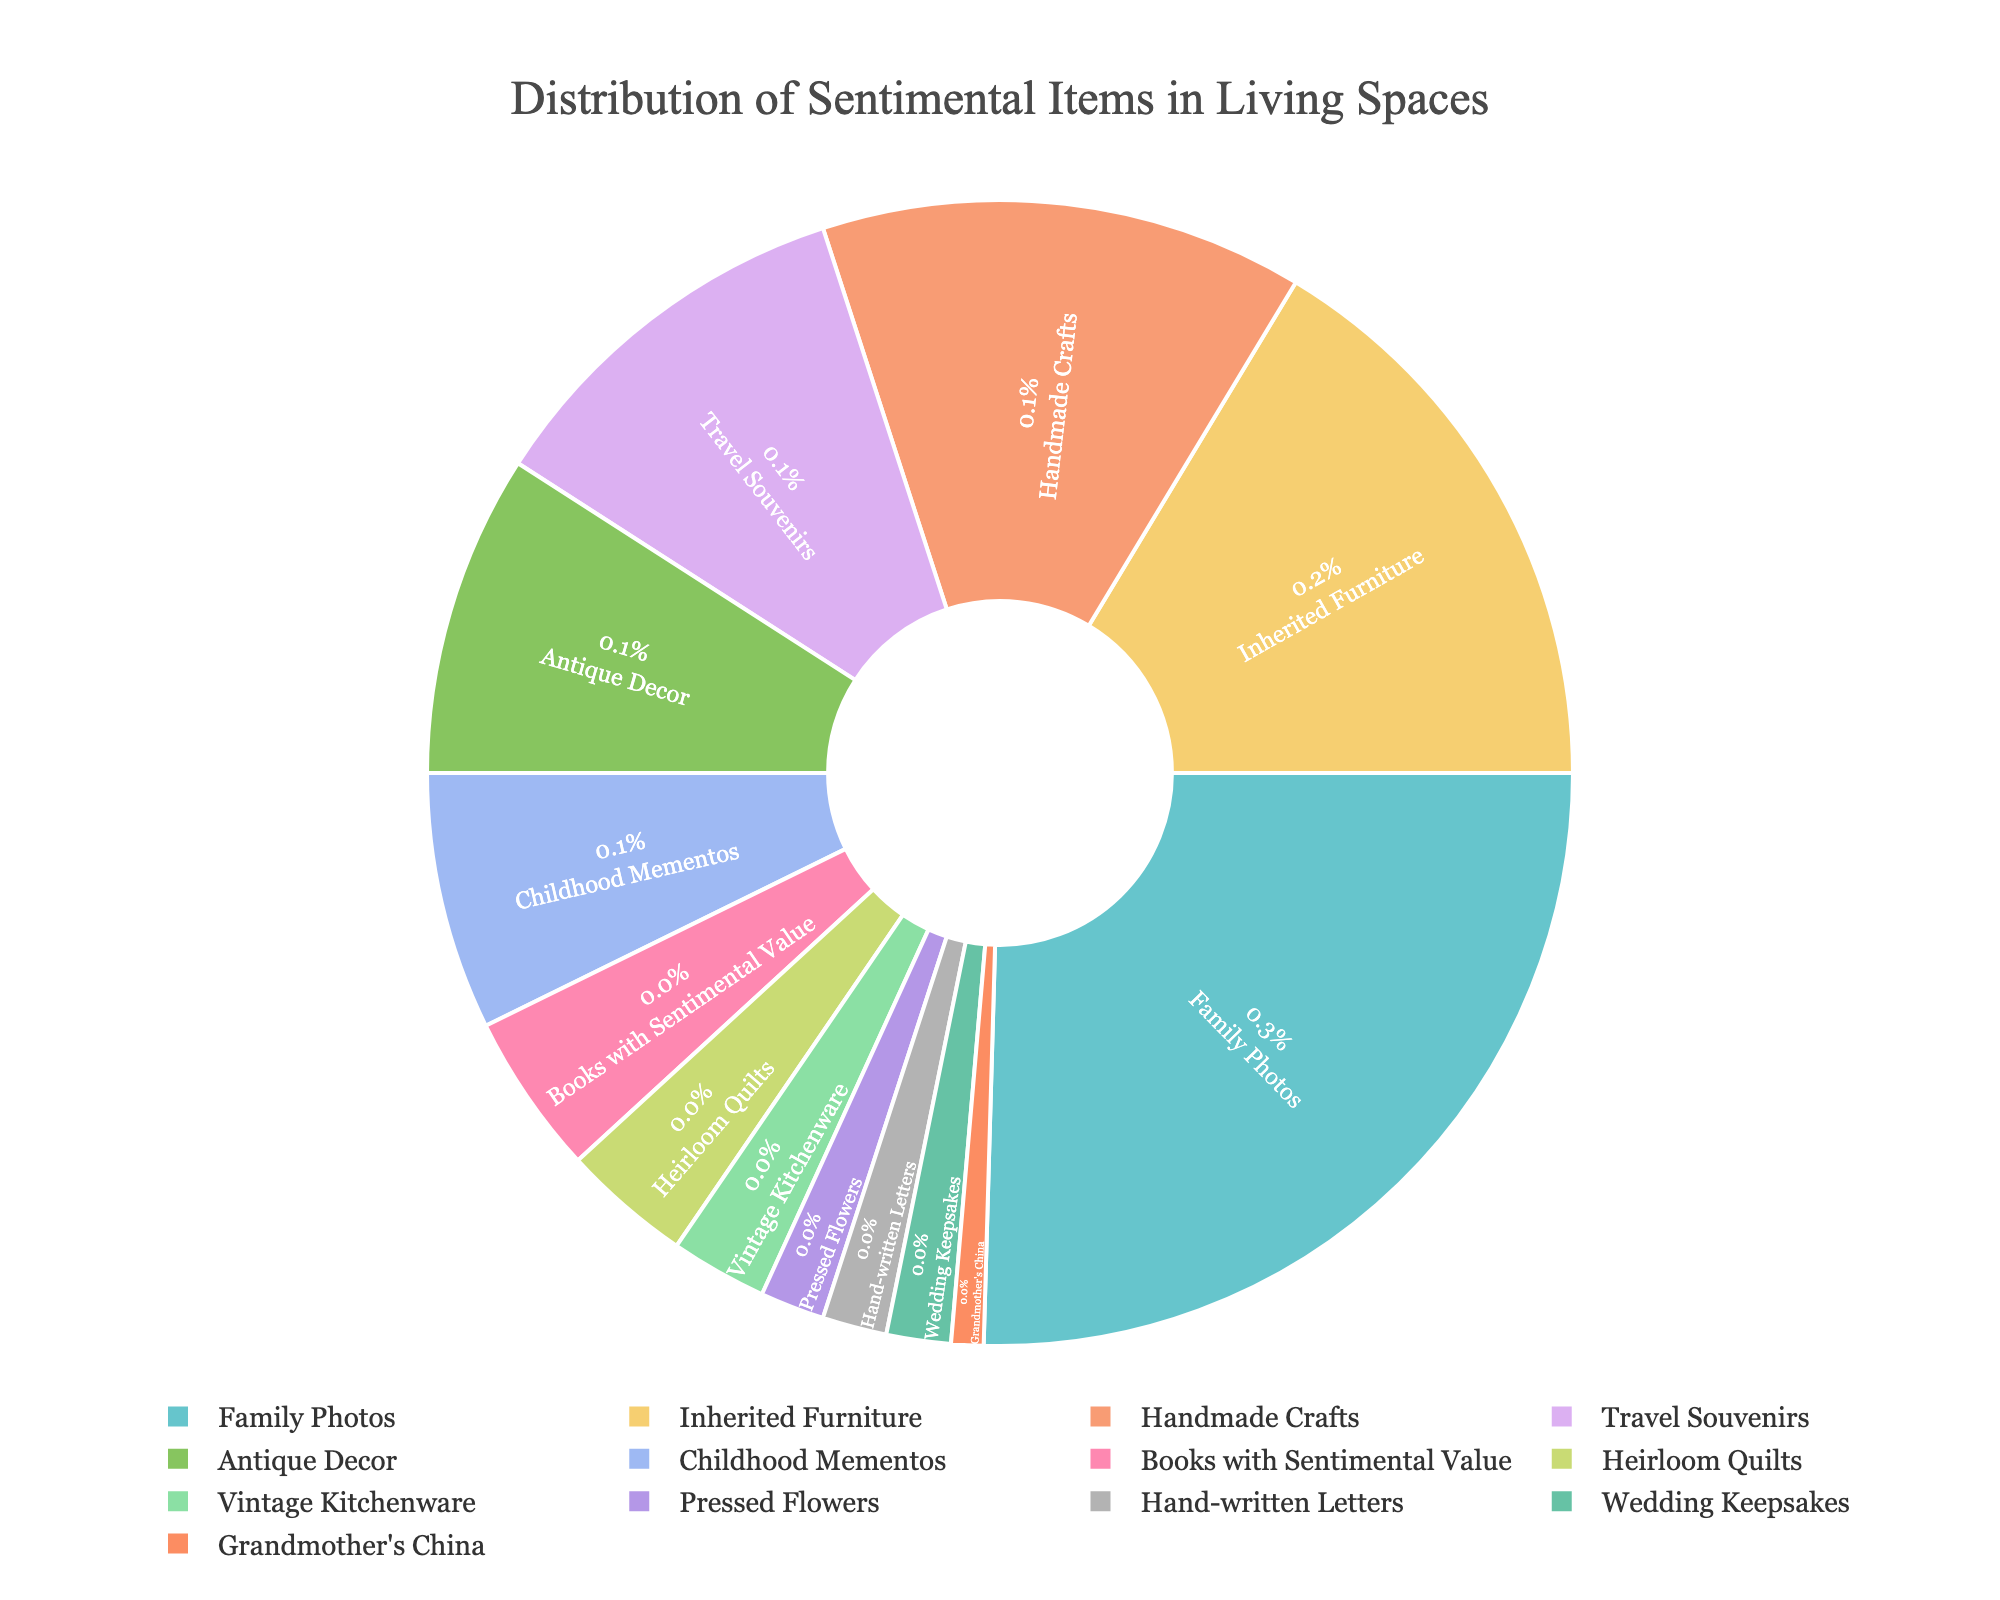What percentage of the sentimental items consists of Family Photos and Inherited Furniture combined? To determine the combined percentage, add the percentage of Family Photos (28%) to the percentage of Inherited Furniture (18%). The total is 28% + 18% = 46%.
Answer: 46% Which category has a higher percentage, Travel Souvenirs or Antique Decor? Travel Souvenirs are at 12%, and Antique Decor is at 10%. Since 12% is greater than 10%, Travel Souvenirs have a higher percentage.
Answer: Travel Souvenirs What is the least common sentimental item displayed in living spaces? From the pie chart, the least common item displayed in living spaces is Grandmother's China, which represents 1% of the total.
Answer: Grandmother's China How much greater is the percentage of Handmade Crafts compared to Books with Sentimental Value? Handmade Crafts are at 15%, and Books with Sentimental Value are at 5%. The difference is 15% - 5% = 10%.
Answer: 10% If you combine the percentages of Childhood Mementos, Heirloom Quilts, and Vintage Kitchenware, what is the total? To find the combined percentage, add Childhood Mementos (8%), Heirloom Quilts (4%), and Vintage Kitchenware (3%). The total is 8% + 4% + 3% = 15%.
Answer: 15% Are Family Photos less than three times the percentage of Travel Souvenirs? Family Photos are at 28%, and Travel Souvenirs are at 12%. Three times the percentage of Travel Souvenirs is 3 * 12% = 36%. Since 28% is less than 36%, Family Photos are indeed less than three times the percentage of Travel Souvenirs.
Answer: Yes Which categories each make up exactly 2% of the sentimental items? From the pie chart, Pressed Flowers, Hand-written Letters, and Wedding Keepsakes each make up exactly 2% of the sentimental items displayed.
Answer: Pressed Flowers, Hand-written Letters, Wedding Keepsakes What is the average percentage of the three most common categories of sentimental items? The three most common categories are Family Photos (28%), Inherited Furniture (18%), and Handmade Crafts (15%). To find the average, add these percentages and divide by 3: (28% + 18% + 15%) / 3 = 61% / 3 = 20.33%.
Answer: 20.33% How does the percentage of Inherited Furniture compare to Handmade Crafts? Inherited Furniture is at 18%, and Handmade Crafts are at 15%. Since 18% is greater than 15%, Inherited Furniture has a higher percentage.
Answer: Inherited Furniture 